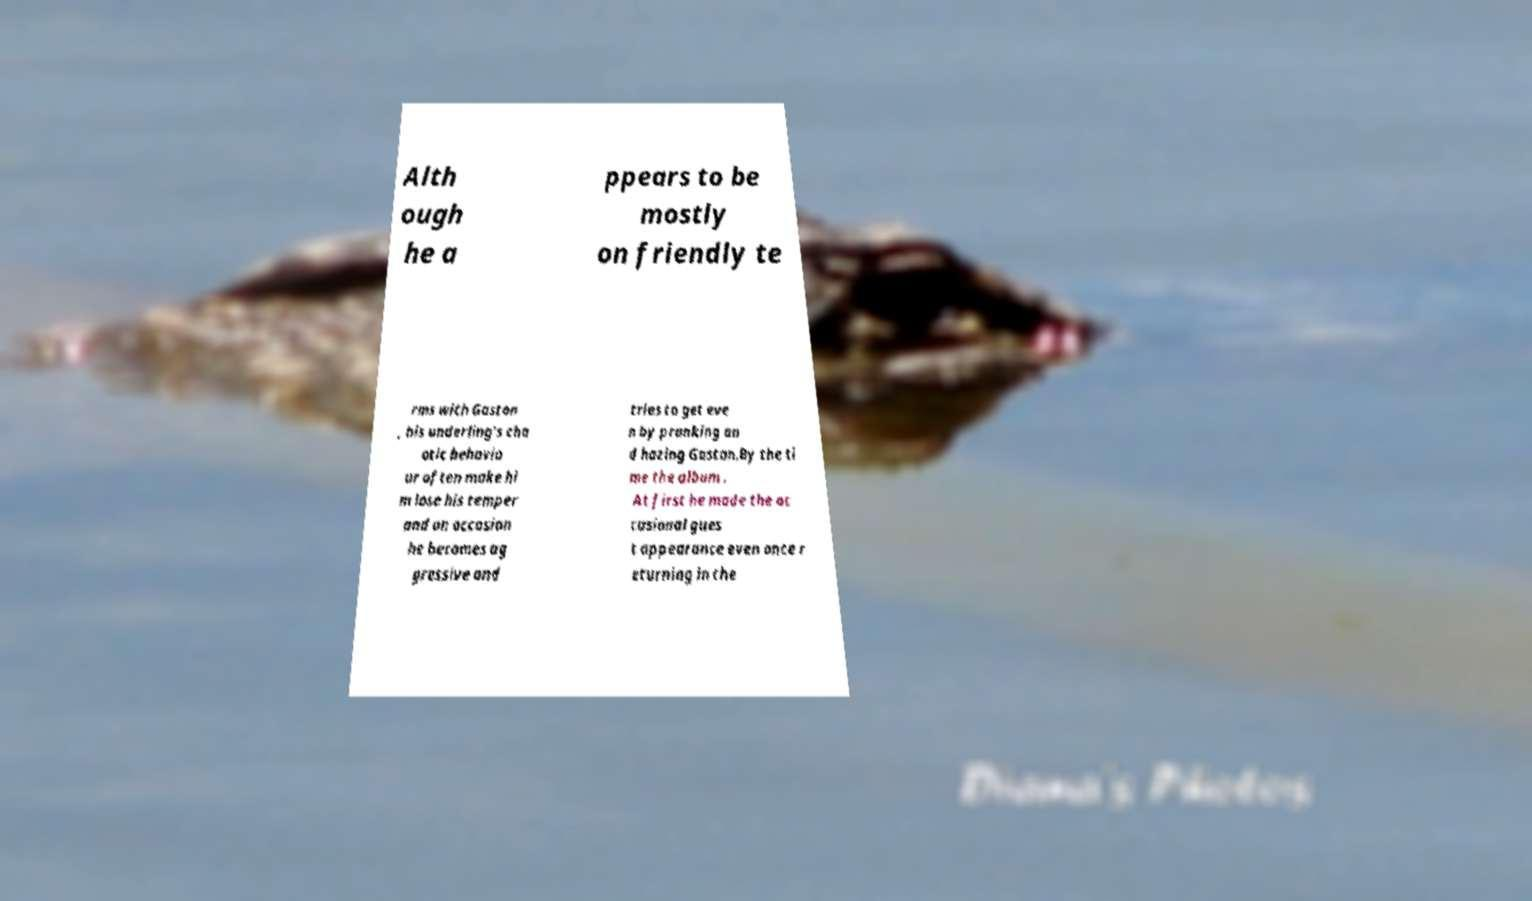Could you assist in decoding the text presented in this image and type it out clearly? Alth ough he a ppears to be mostly on friendly te rms with Gaston , his underling's cha otic behavio ur often make hi m lose his temper and on occasion he becomes ag gressive and tries to get eve n by pranking an d hazing Gaston.By the ti me the album . At first he made the oc casional gues t appearance even once r eturning in the 